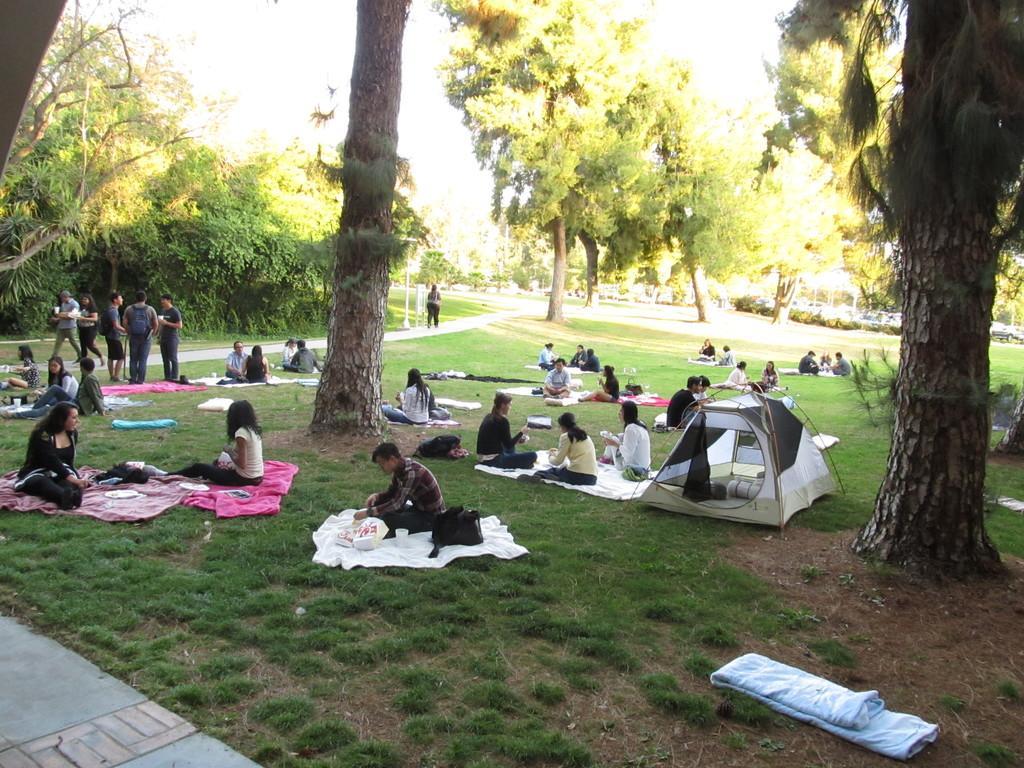How would you summarize this image in a sentence or two? In this picture I can see group of people standing, there are clothes and some other objects on the grass, there are group of people sitting on the clothes, there is a tent, and in the background there are trees. 